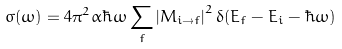<formula> <loc_0><loc_0><loc_500><loc_500>\sigma ( \omega ) = 4 \pi ^ { 2 } \alpha \hbar { \omega } \sum _ { f } \left | M _ { i \rightarrow f } \right | ^ { 2 } \delta ( E _ { f } - E _ { i } - \hbar { \omega } )</formula> 